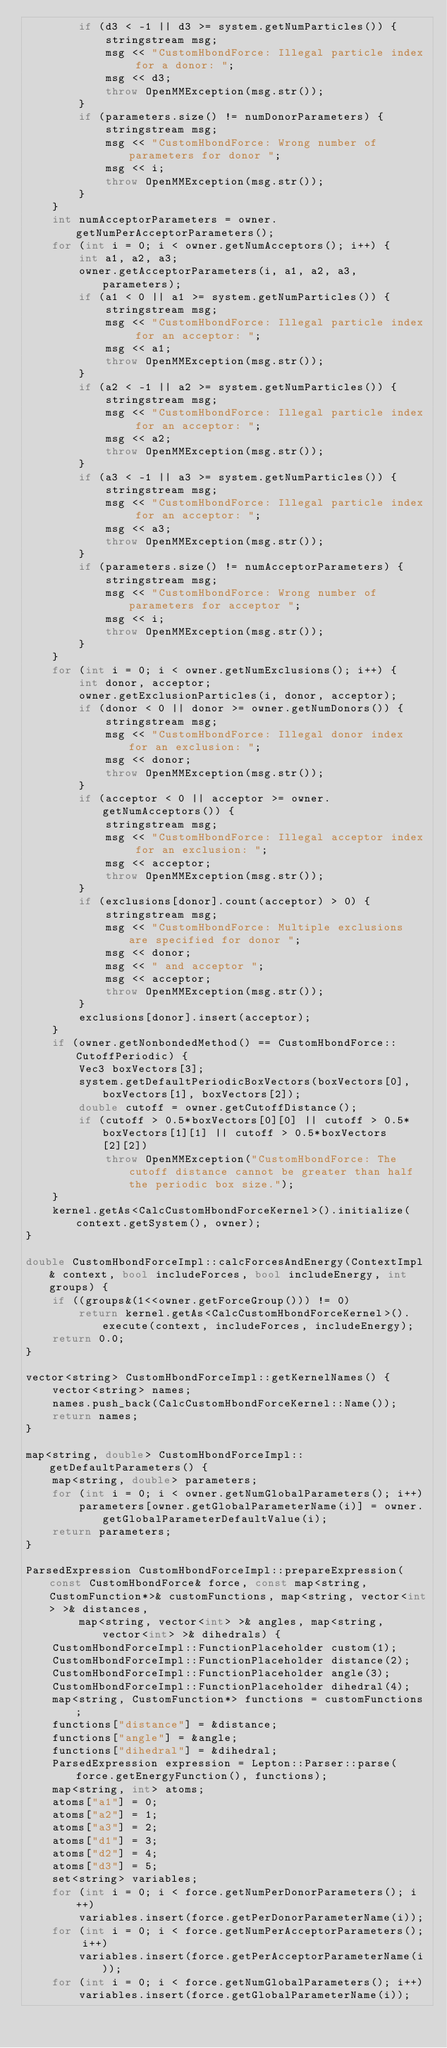Convert code to text. <code><loc_0><loc_0><loc_500><loc_500><_C++_>        if (d3 < -1 || d3 >= system.getNumParticles()) {
            stringstream msg;
            msg << "CustomHbondForce: Illegal particle index for a donor: ";
            msg << d3;
            throw OpenMMException(msg.str());
        }
        if (parameters.size() != numDonorParameters) {
            stringstream msg;
            msg << "CustomHbondForce: Wrong number of parameters for donor ";
            msg << i;
            throw OpenMMException(msg.str());
        }
    }
    int numAcceptorParameters = owner.getNumPerAcceptorParameters();
    for (int i = 0; i < owner.getNumAcceptors(); i++) {
        int a1, a2, a3;
        owner.getAcceptorParameters(i, a1, a2, a3, parameters);
        if (a1 < 0 || a1 >= system.getNumParticles()) {
            stringstream msg;
            msg << "CustomHbondForce: Illegal particle index for an acceptor: ";
            msg << a1;
            throw OpenMMException(msg.str());
        }
        if (a2 < -1 || a2 >= system.getNumParticles()) {
            stringstream msg;
            msg << "CustomHbondForce: Illegal particle index for an acceptor: ";
            msg << a2;
            throw OpenMMException(msg.str());
        }
        if (a3 < -1 || a3 >= system.getNumParticles()) {
            stringstream msg;
            msg << "CustomHbondForce: Illegal particle index for an acceptor: ";
            msg << a3;
            throw OpenMMException(msg.str());
        }
        if (parameters.size() != numAcceptorParameters) {
            stringstream msg;
            msg << "CustomHbondForce: Wrong number of parameters for acceptor ";
            msg << i;
            throw OpenMMException(msg.str());
        }
    }
    for (int i = 0; i < owner.getNumExclusions(); i++) {
        int donor, acceptor;
        owner.getExclusionParticles(i, donor, acceptor);
        if (donor < 0 || donor >= owner.getNumDonors()) {
            stringstream msg;
            msg << "CustomHbondForce: Illegal donor index for an exclusion: ";
            msg << donor;
            throw OpenMMException(msg.str());
        }
        if (acceptor < 0 || acceptor >= owner.getNumAcceptors()) {
            stringstream msg;
            msg << "CustomHbondForce: Illegal acceptor index for an exclusion: ";
            msg << acceptor;
            throw OpenMMException(msg.str());
        }
        if (exclusions[donor].count(acceptor) > 0) {
            stringstream msg;
            msg << "CustomHbondForce: Multiple exclusions are specified for donor ";
            msg << donor;
            msg << " and acceptor ";
            msg << acceptor;
            throw OpenMMException(msg.str());
        }
        exclusions[donor].insert(acceptor);
    }
    if (owner.getNonbondedMethod() == CustomHbondForce::CutoffPeriodic) {
        Vec3 boxVectors[3];
        system.getDefaultPeriodicBoxVectors(boxVectors[0], boxVectors[1], boxVectors[2]);
        double cutoff = owner.getCutoffDistance();
        if (cutoff > 0.5*boxVectors[0][0] || cutoff > 0.5*boxVectors[1][1] || cutoff > 0.5*boxVectors[2][2])
            throw OpenMMException("CustomHbondForce: The cutoff distance cannot be greater than half the periodic box size.");
    }
    kernel.getAs<CalcCustomHbondForceKernel>().initialize(context.getSystem(), owner);
}

double CustomHbondForceImpl::calcForcesAndEnergy(ContextImpl& context, bool includeForces, bool includeEnergy, int groups) {
    if ((groups&(1<<owner.getForceGroup())) != 0)
        return kernel.getAs<CalcCustomHbondForceKernel>().execute(context, includeForces, includeEnergy);
    return 0.0;
}

vector<string> CustomHbondForceImpl::getKernelNames() {
    vector<string> names;
    names.push_back(CalcCustomHbondForceKernel::Name());
    return names;
}

map<string, double> CustomHbondForceImpl::getDefaultParameters() {
    map<string, double> parameters;
    for (int i = 0; i < owner.getNumGlobalParameters(); i++)
        parameters[owner.getGlobalParameterName(i)] = owner.getGlobalParameterDefaultValue(i);
    return parameters;
}

ParsedExpression CustomHbondForceImpl::prepareExpression(const CustomHbondForce& force, const map<string, CustomFunction*>& customFunctions, map<string, vector<int> >& distances,
        map<string, vector<int> >& angles, map<string, vector<int> >& dihedrals) {
    CustomHbondForceImpl::FunctionPlaceholder custom(1);
    CustomHbondForceImpl::FunctionPlaceholder distance(2);
    CustomHbondForceImpl::FunctionPlaceholder angle(3);
    CustomHbondForceImpl::FunctionPlaceholder dihedral(4);
    map<string, CustomFunction*> functions = customFunctions;
    functions["distance"] = &distance;
    functions["angle"] = &angle;
    functions["dihedral"] = &dihedral;
    ParsedExpression expression = Lepton::Parser::parse(force.getEnergyFunction(), functions);
    map<string, int> atoms;
    atoms["a1"] = 0;
    atoms["a2"] = 1;
    atoms["a3"] = 2;
    atoms["d1"] = 3;
    atoms["d2"] = 4;
    atoms["d3"] = 5;
    set<string> variables;
    for (int i = 0; i < force.getNumPerDonorParameters(); i++)
        variables.insert(force.getPerDonorParameterName(i));
    for (int i = 0; i < force.getNumPerAcceptorParameters(); i++)
        variables.insert(force.getPerAcceptorParameterName(i));
    for (int i = 0; i < force.getNumGlobalParameters(); i++)
        variables.insert(force.getGlobalParameterName(i));</code> 